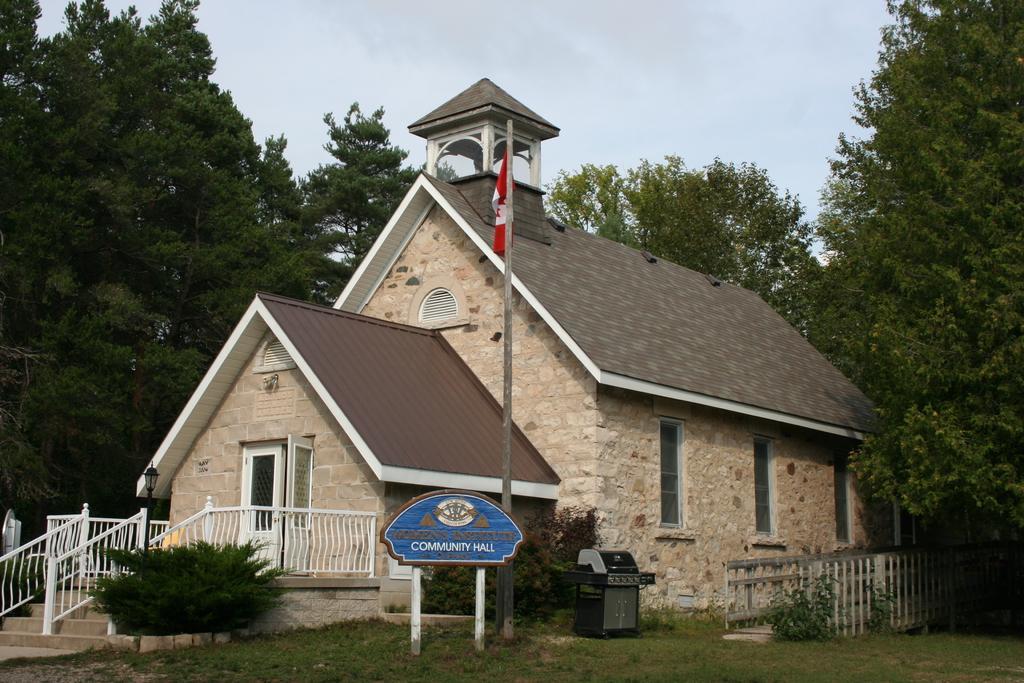Describe this image in one or two sentences. This picture is clicked outside. In the center we can see the house and we can see the door and the windows of the house and there is a flag and a board attached to the poles and we can see the hand rails, stairs, fence, dust bin, plants and trees. In the background there is a sky. 